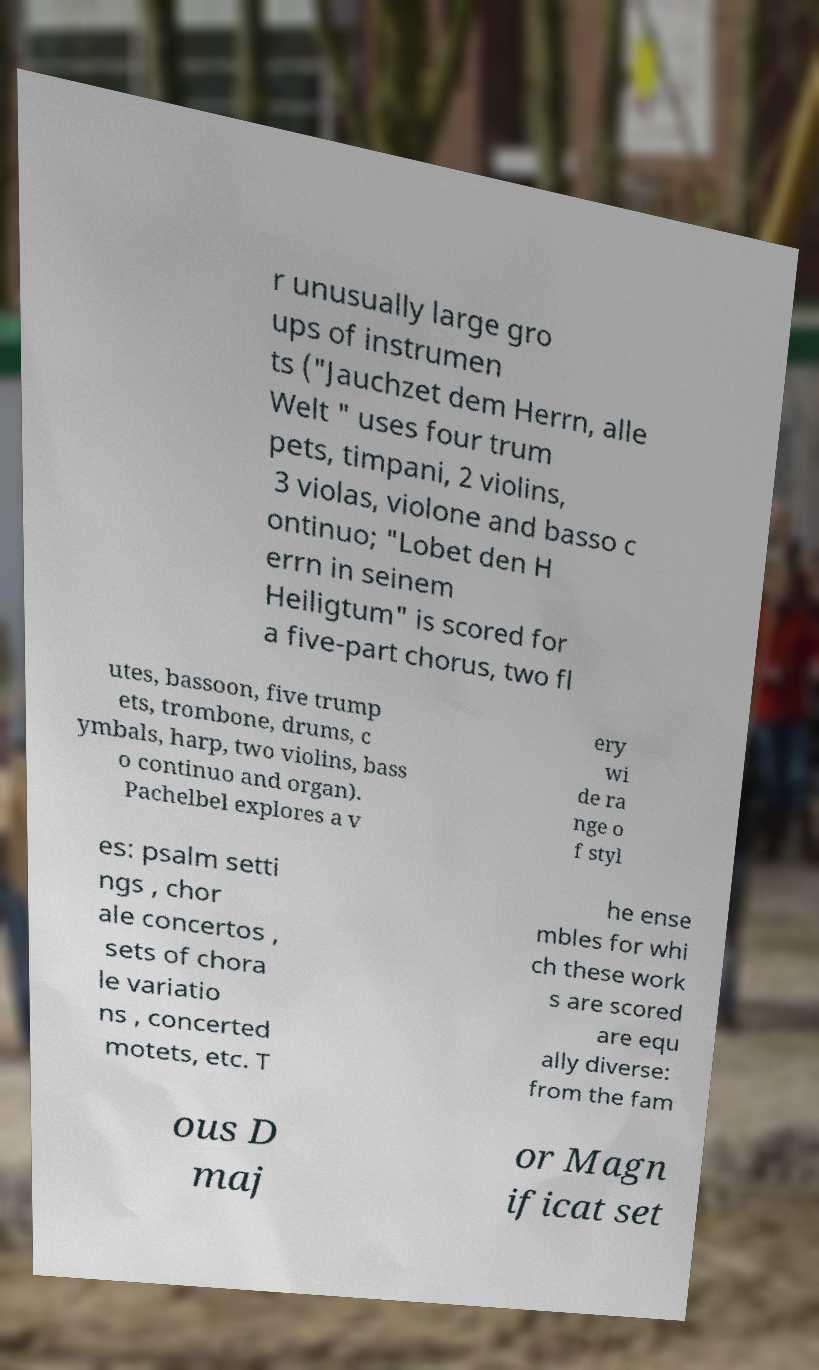I need the written content from this picture converted into text. Can you do that? r unusually large gro ups of instrumen ts ("Jauchzet dem Herrn, alle Welt " uses four trum pets, timpani, 2 violins, 3 violas, violone and basso c ontinuo; "Lobet den H errn in seinem Heiligtum" is scored for a five-part chorus, two fl utes, bassoon, five trump ets, trombone, drums, c ymbals, harp, two violins, bass o continuo and organ). Pachelbel explores a v ery wi de ra nge o f styl es: psalm setti ngs , chor ale concertos , sets of chora le variatio ns , concerted motets, etc. T he ense mbles for whi ch these work s are scored are equ ally diverse: from the fam ous D maj or Magn ificat set 